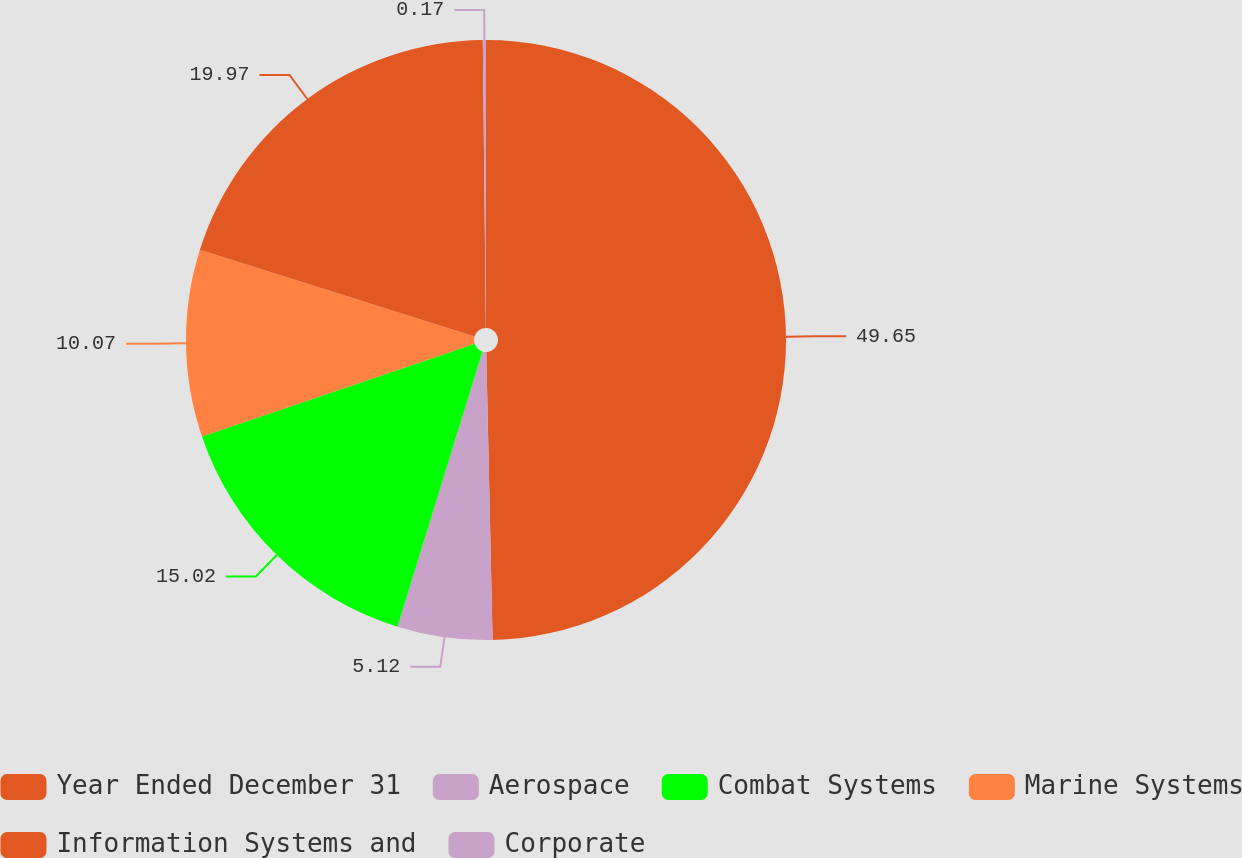Convert chart to OTSL. <chart><loc_0><loc_0><loc_500><loc_500><pie_chart><fcel>Year Ended December 31<fcel>Aerospace<fcel>Combat Systems<fcel>Marine Systems<fcel>Information Systems and<fcel>Corporate<nl><fcel>49.65%<fcel>5.12%<fcel>15.02%<fcel>10.07%<fcel>19.97%<fcel>0.17%<nl></chart> 